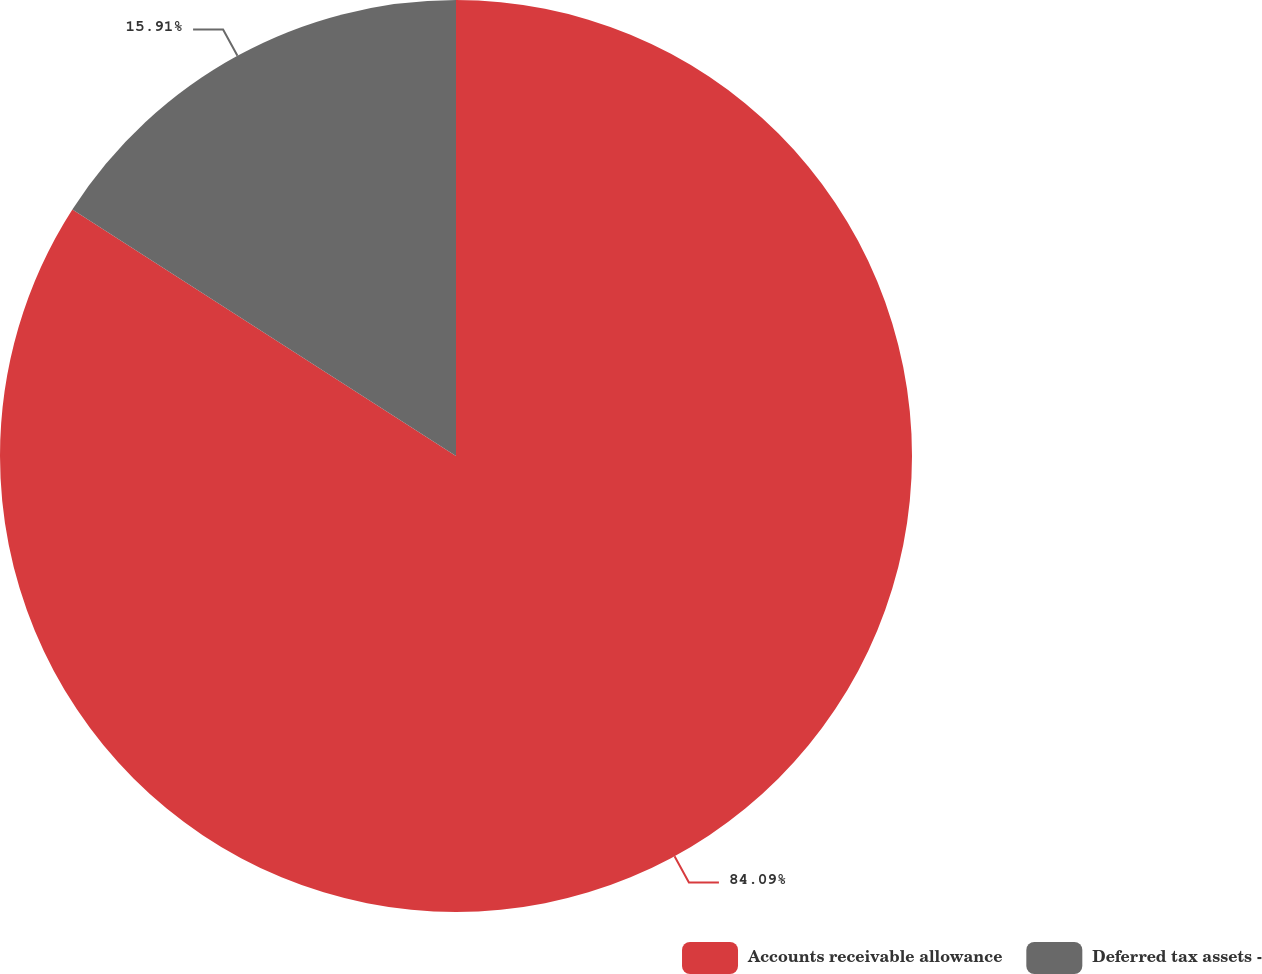Convert chart to OTSL. <chart><loc_0><loc_0><loc_500><loc_500><pie_chart><fcel>Accounts receivable allowance<fcel>Deferred tax assets -<nl><fcel>84.09%<fcel>15.91%<nl></chart> 